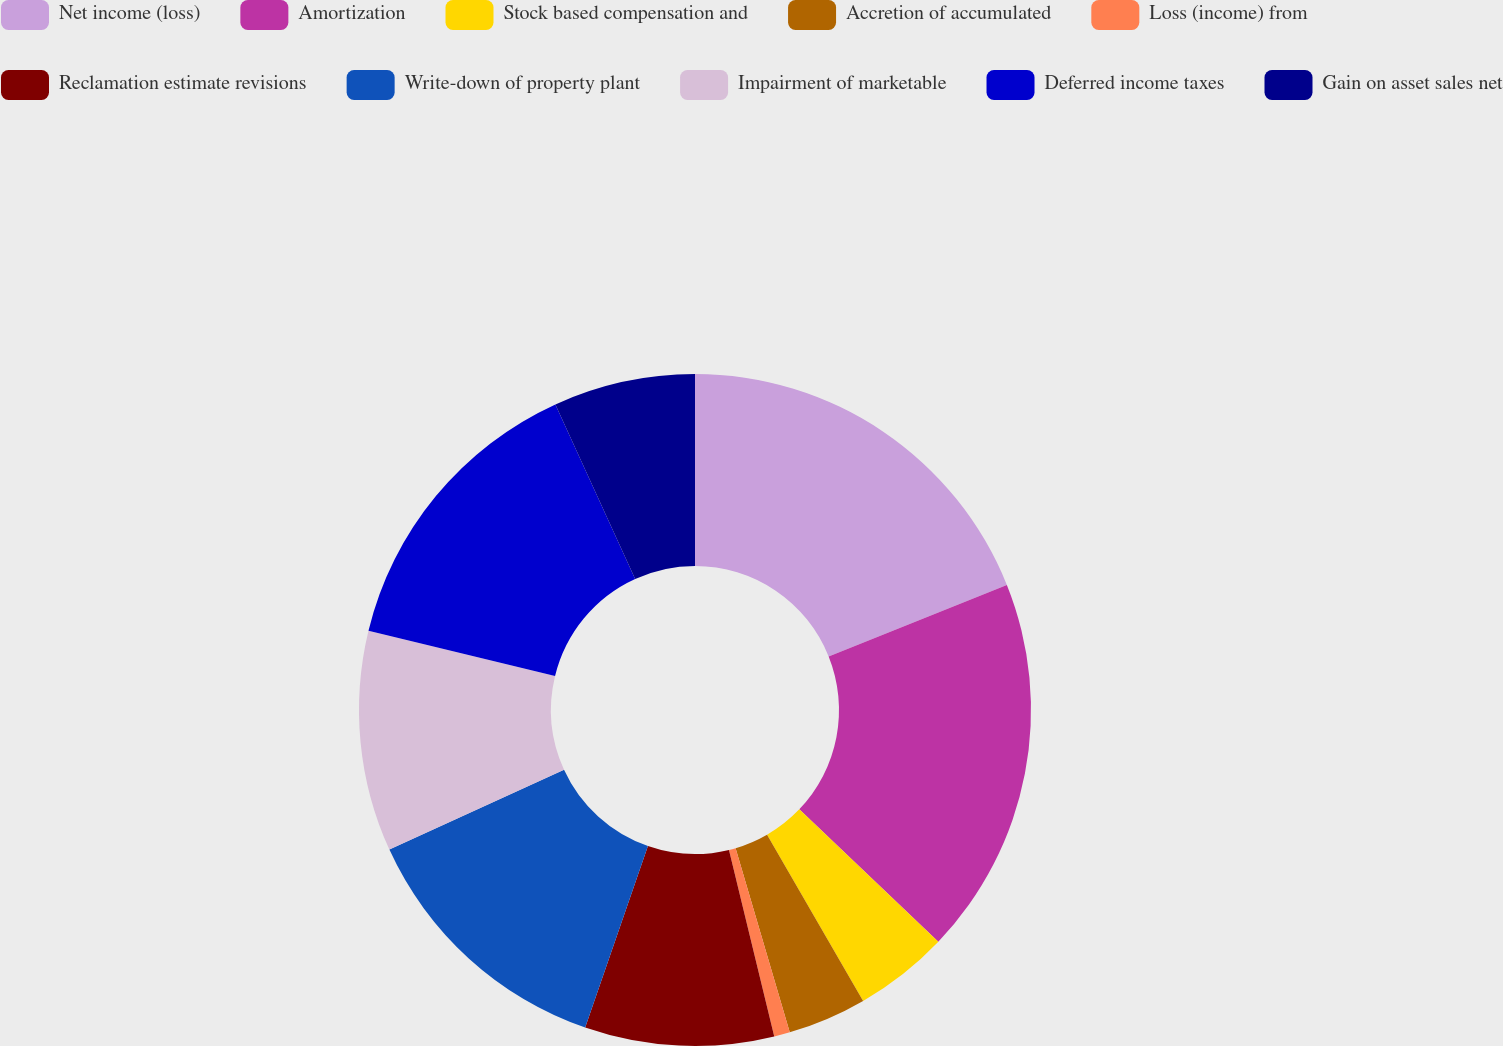<chart> <loc_0><loc_0><loc_500><loc_500><pie_chart><fcel>Net income (loss)<fcel>Amortization<fcel>Stock based compensation and<fcel>Accretion of accumulated<fcel>Loss (income) from<fcel>Reclamation estimate revisions<fcel>Write-down of property plant<fcel>Impairment of marketable<fcel>Deferred income taxes<fcel>Gain on asset sales net<nl><fcel>18.93%<fcel>18.18%<fcel>4.55%<fcel>3.79%<fcel>0.76%<fcel>9.09%<fcel>12.88%<fcel>10.61%<fcel>14.39%<fcel>6.82%<nl></chart> 